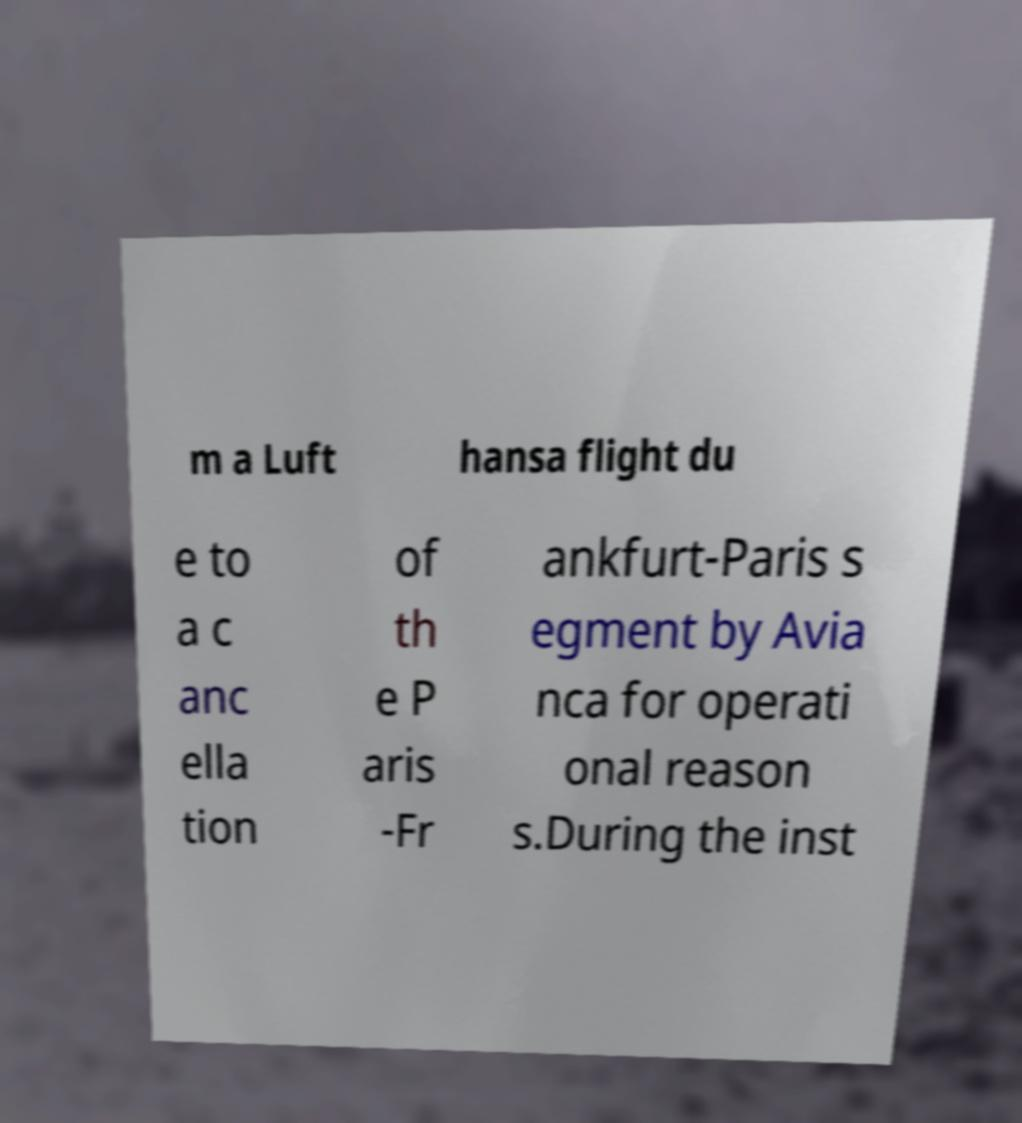Can you accurately transcribe the text from the provided image for me? m a Luft hansa flight du e to a c anc ella tion of th e P aris -Fr ankfurt-Paris s egment by Avia nca for operati onal reason s.During the inst 